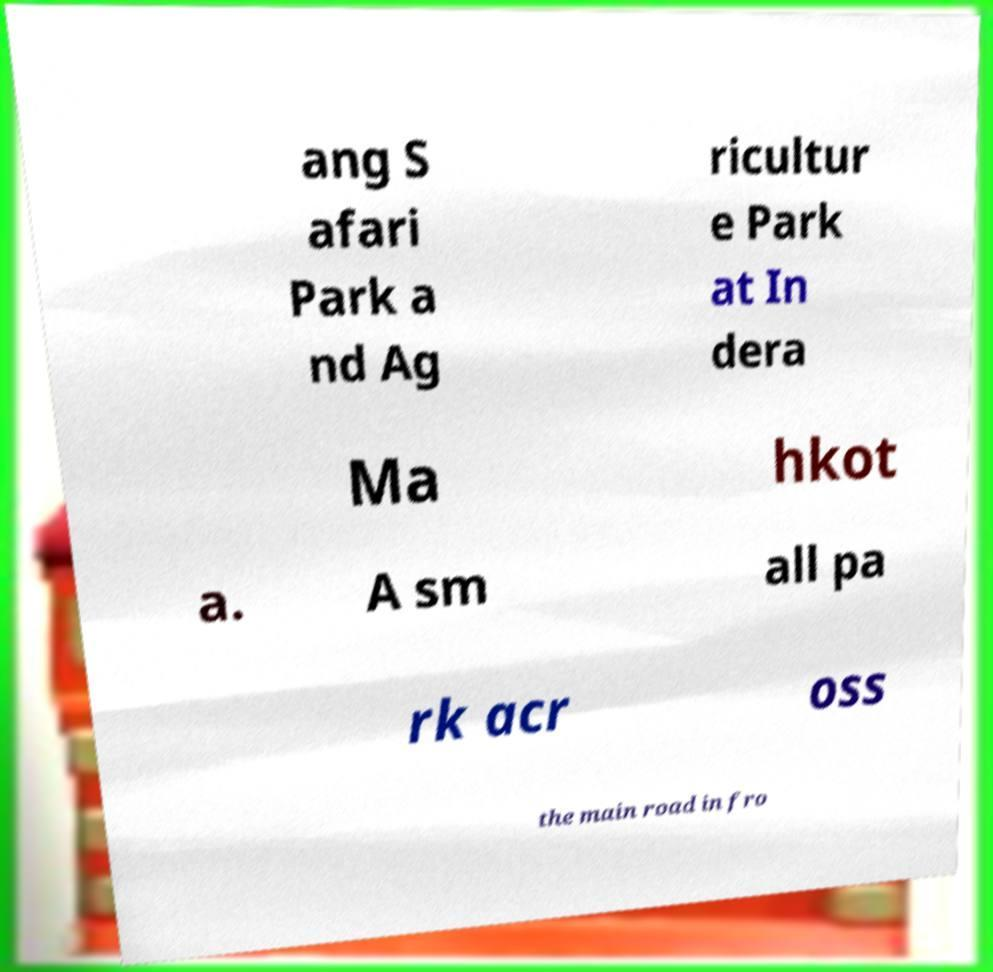I need the written content from this picture converted into text. Can you do that? ang S afari Park a nd Ag ricultur e Park at In dera Ma hkot a. A sm all pa rk acr oss the main road in fro 